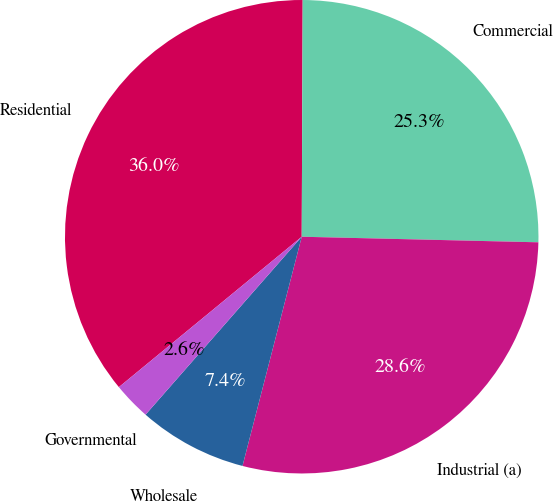Convert chart to OTSL. <chart><loc_0><loc_0><loc_500><loc_500><pie_chart><fcel>Residential<fcel>Commercial<fcel>Industrial (a)<fcel>Wholesale<fcel>Governmental<nl><fcel>36.02%<fcel>25.31%<fcel>28.65%<fcel>7.44%<fcel>2.58%<nl></chart> 